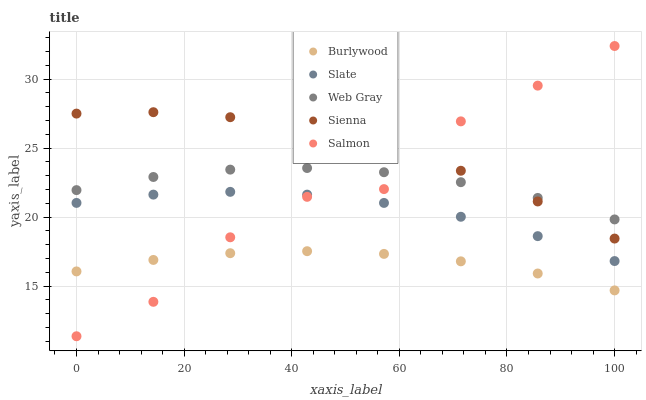Does Burlywood have the minimum area under the curve?
Answer yes or no. Yes. Does Sienna have the maximum area under the curve?
Answer yes or no. Yes. Does Slate have the minimum area under the curve?
Answer yes or no. No. Does Slate have the maximum area under the curve?
Answer yes or no. No. Is Burlywood the smoothest?
Answer yes or no. Yes. Is Salmon the roughest?
Answer yes or no. Yes. Is Sienna the smoothest?
Answer yes or no. No. Is Sienna the roughest?
Answer yes or no. No. Does Salmon have the lowest value?
Answer yes or no. Yes. Does Sienna have the lowest value?
Answer yes or no. No. Does Salmon have the highest value?
Answer yes or no. Yes. Does Sienna have the highest value?
Answer yes or no. No. Is Slate less than Web Gray?
Answer yes or no. Yes. Is Sienna greater than Burlywood?
Answer yes or no. Yes. Does Slate intersect Salmon?
Answer yes or no. Yes. Is Slate less than Salmon?
Answer yes or no. No. Is Slate greater than Salmon?
Answer yes or no. No. Does Slate intersect Web Gray?
Answer yes or no. No. 